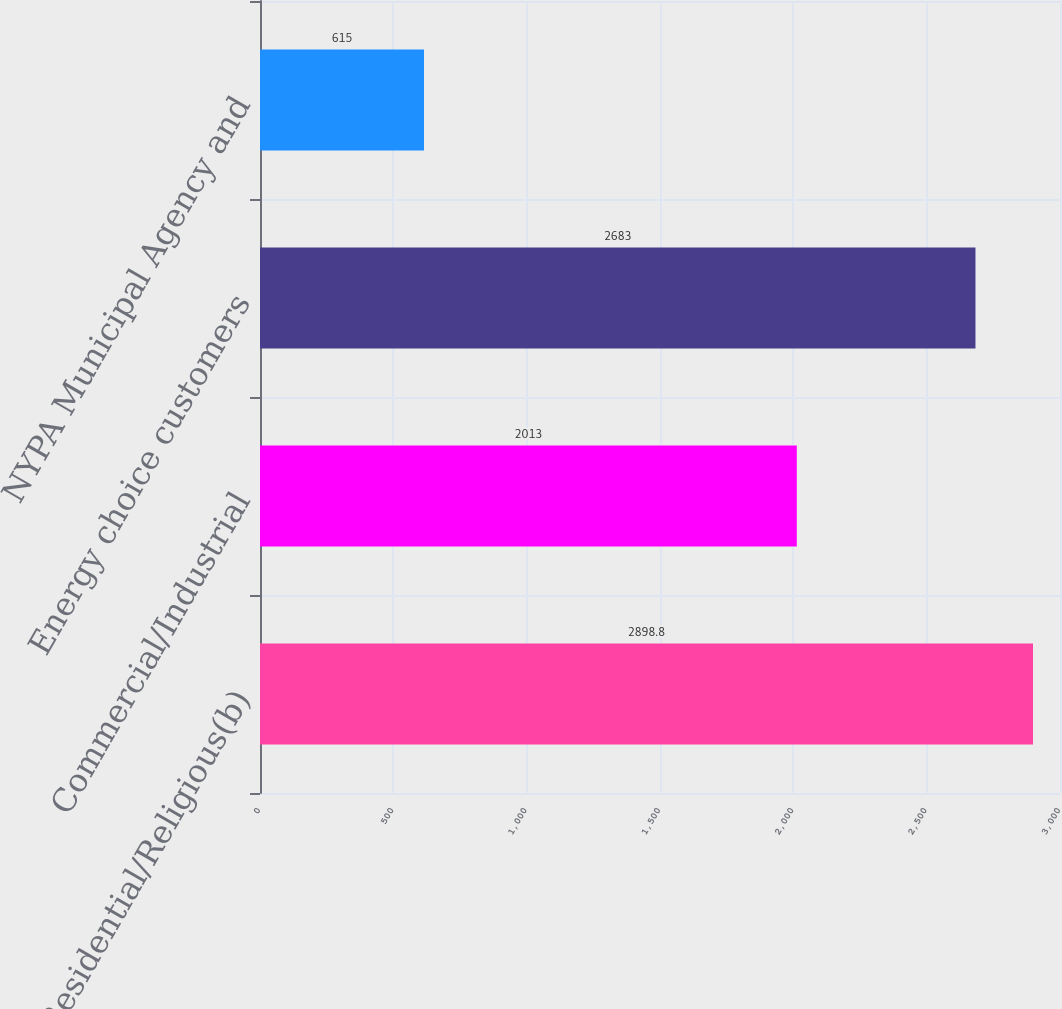<chart> <loc_0><loc_0><loc_500><loc_500><bar_chart><fcel>Residential/Religious(b)<fcel>Commercial/Industrial<fcel>Energy choice customers<fcel>NYPA Municipal Agency and<nl><fcel>2898.8<fcel>2013<fcel>2683<fcel>615<nl></chart> 